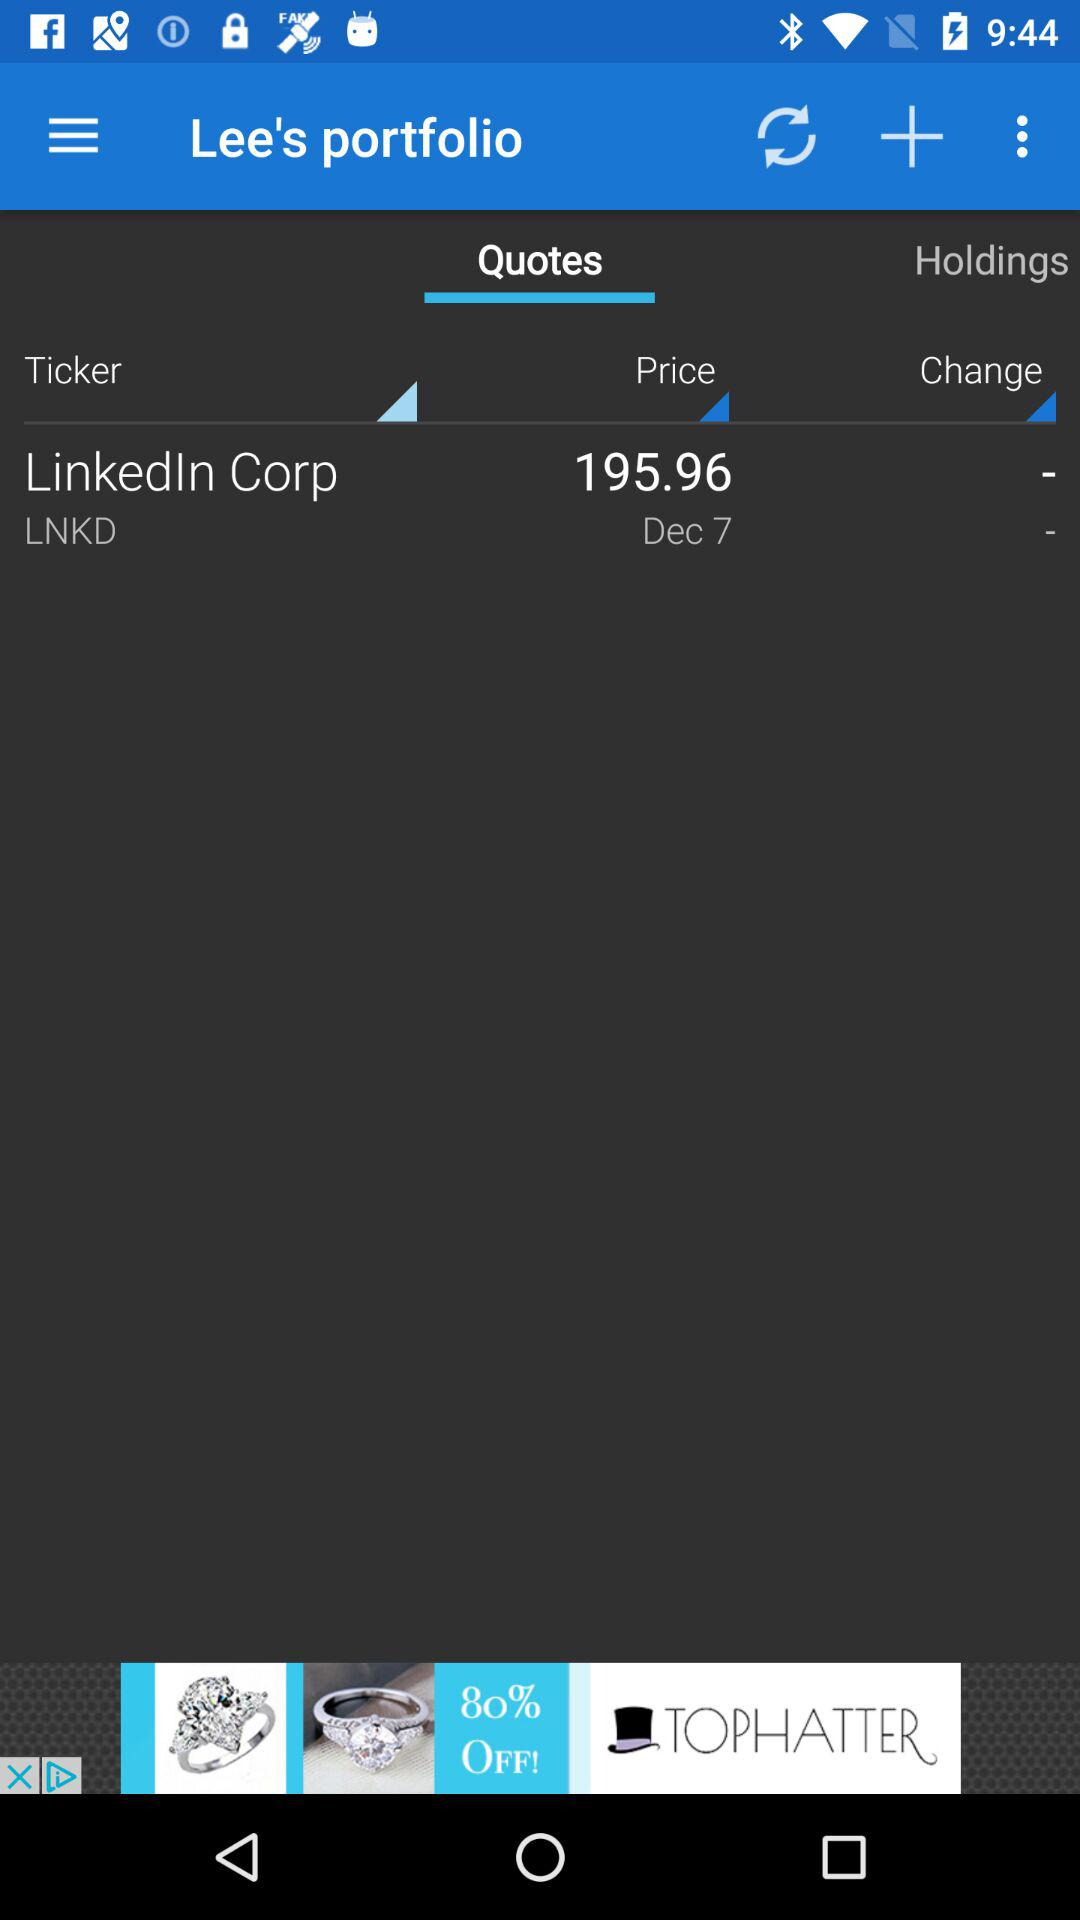What is the price? The price is 195.96. 